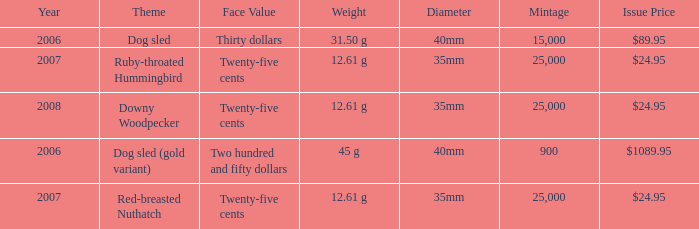What is the MIntage after 2006 of the Ruby-Throated Hummingbird Theme coin? 25000.0. 